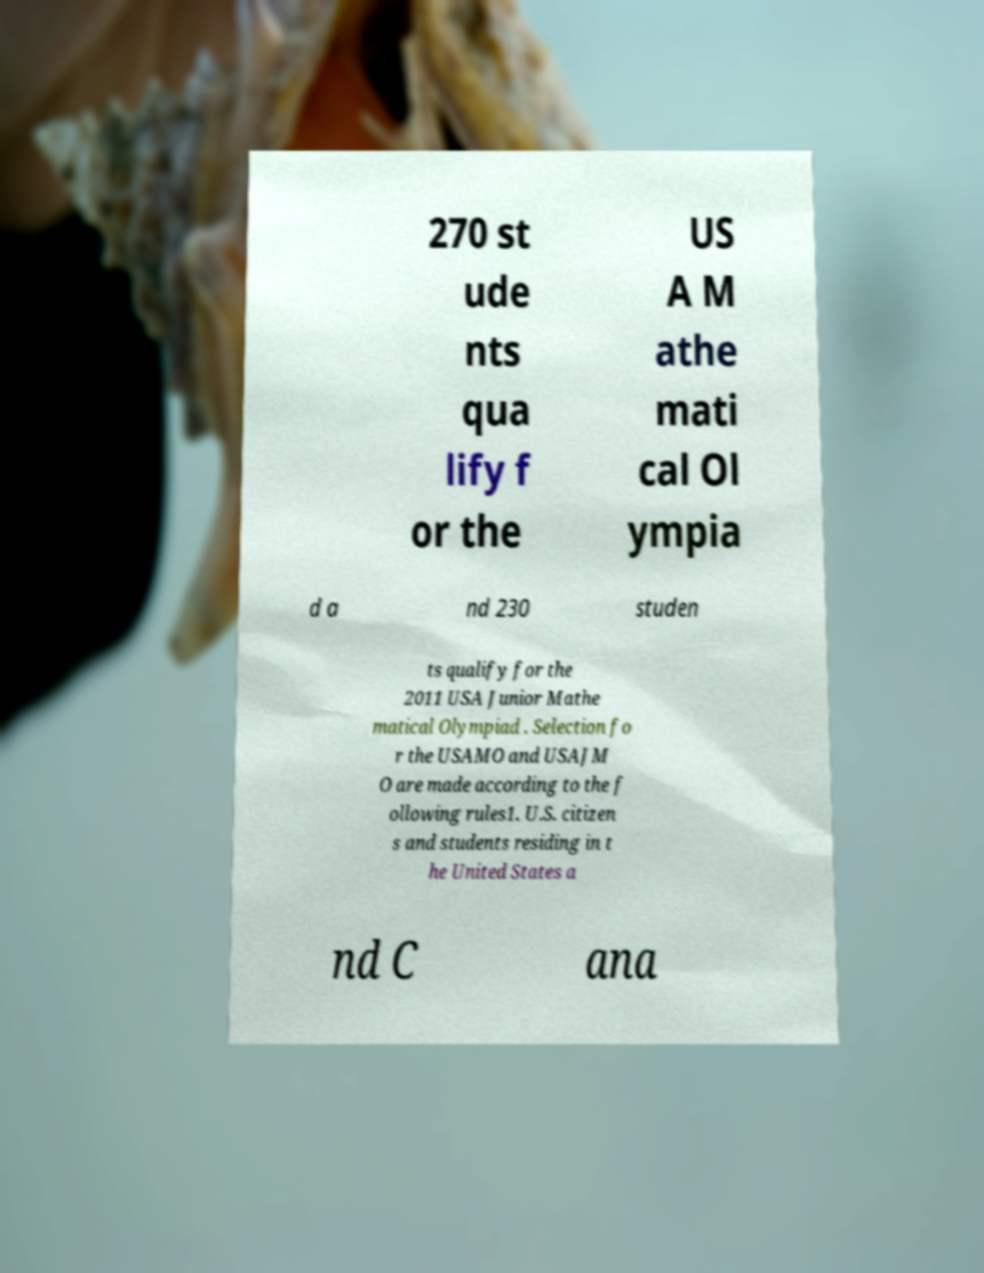Can you accurately transcribe the text from the provided image for me? 270 st ude nts qua lify f or the US A M athe mati cal Ol ympia d a nd 230 studen ts qualify for the 2011 USA Junior Mathe matical Olympiad . Selection fo r the USAMO and USAJM O are made according to the f ollowing rules1. U.S. citizen s and students residing in t he United States a nd C ana 